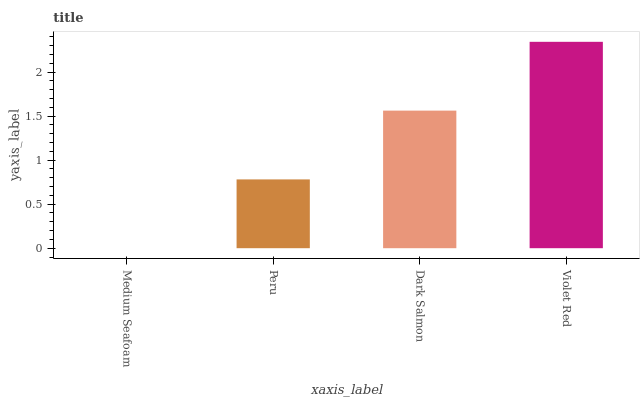Is Peru the minimum?
Answer yes or no. No. Is Peru the maximum?
Answer yes or no. No. Is Peru greater than Medium Seafoam?
Answer yes or no. Yes. Is Medium Seafoam less than Peru?
Answer yes or no. Yes. Is Medium Seafoam greater than Peru?
Answer yes or no. No. Is Peru less than Medium Seafoam?
Answer yes or no. No. Is Dark Salmon the high median?
Answer yes or no. Yes. Is Peru the low median?
Answer yes or no. Yes. Is Violet Red the high median?
Answer yes or no. No. Is Violet Red the low median?
Answer yes or no. No. 